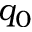Convert formula to latex. <formula><loc_0><loc_0><loc_500><loc_500>q _ { 0 }</formula> 